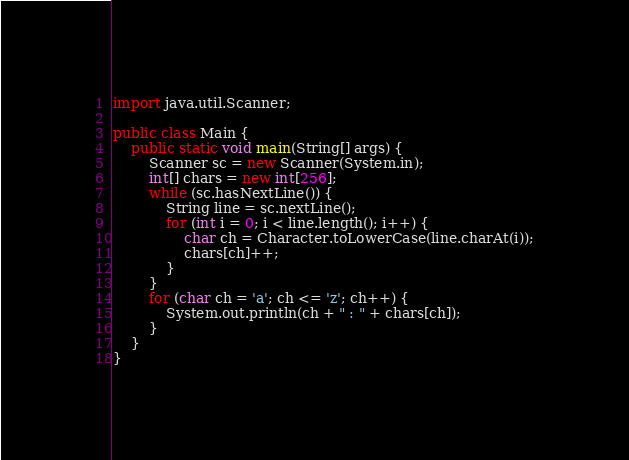Convert code to text. <code><loc_0><loc_0><loc_500><loc_500><_Java_>import java.util.Scanner;

public class Main {
	public static void main(String[] args) {
		Scanner sc = new Scanner(System.in);
		int[] chars = new int[256];
		while (sc.hasNextLine()) {
			String line = sc.nextLine();
			for (int i = 0; i < line.length(); i++) {
				char ch = Character.toLowerCase(line.charAt(i));
				chars[ch]++;
			}
		}
		for (char ch = 'a'; ch <= 'z'; ch++) {
			System.out.println(ch + " : " + chars[ch]);
		}
	}
}</code> 